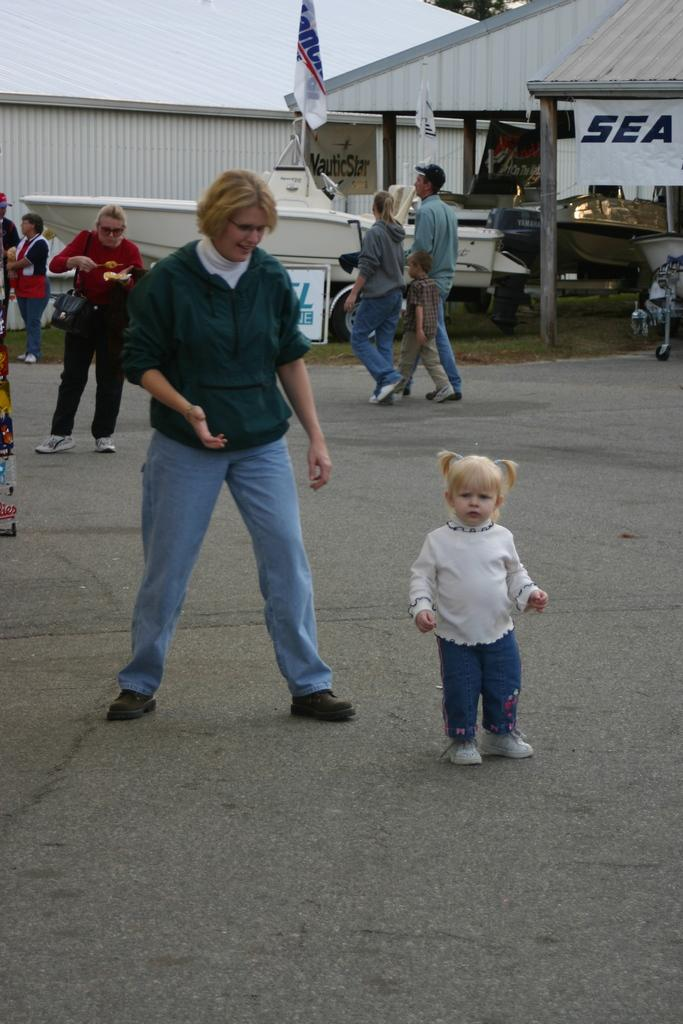How many individuals are present in the image? There are many people in the image. What can be seen in the background of the image? There is a flag in the background of the image. Can you describe the building in the image? There is a building with pillars in the image? What type of knowledge can be gained from the people's toes in the image? There is no information about the people's toes in the image, so no knowledge can be gained from them. 